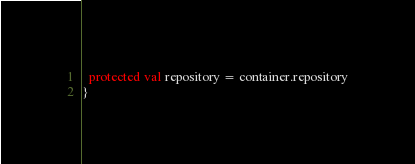<code> <loc_0><loc_0><loc_500><loc_500><_Scala_>  protected val repository = container.repository
}
</code> 